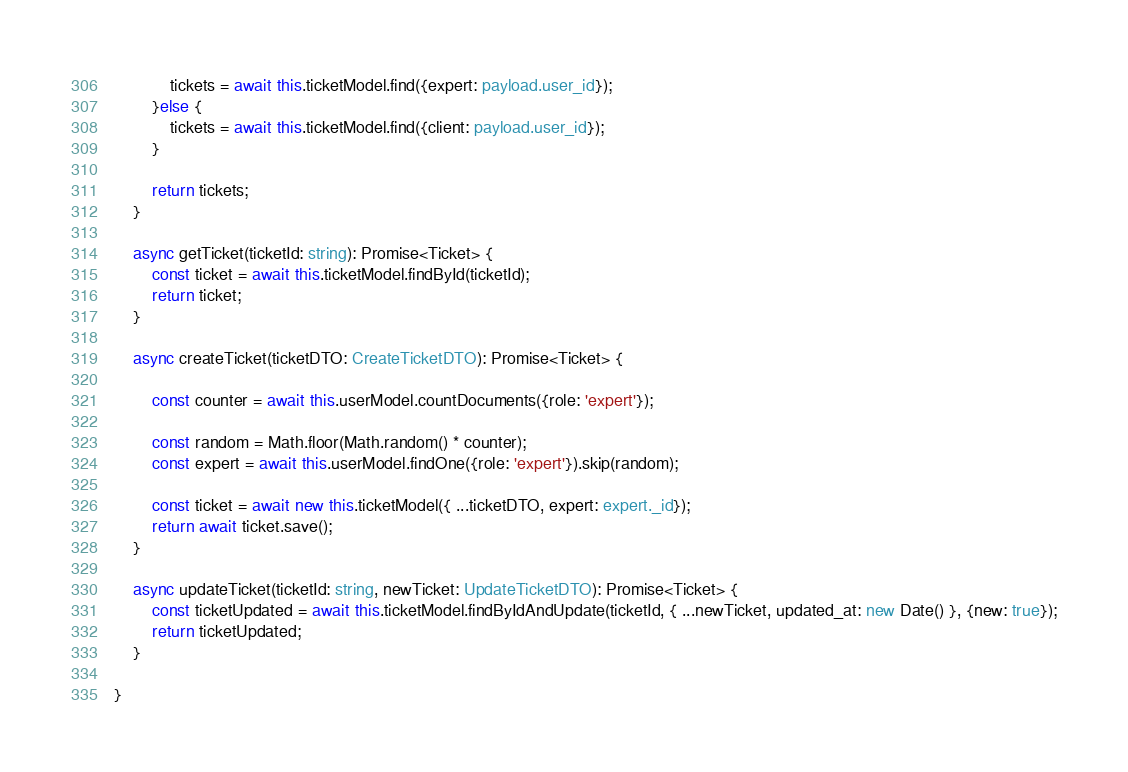Convert code to text. <code><loc_0><loc_0><loc_500><loc_500><_TypeScript_>            tickets = await this.ticketModel.find({expert: payload.user_id});
        }else {
            tickets = await this.ticketModel.find({client: payload.user_id});
        }
        
        return tickets;
    }

    async getTicket(ticketId: string): Promise<Ticket> {
        const ticket = await this.ticketModel.findById(ticketId);
        return ticket;
    }

    async createTicket(ticketDTO: CreateTicketDTO): Promise<Ticket> {

        const counter = await this.userModel.countDocuments({role: 'expert'});

        const random = Math.floor(Math.random() * counter);
        const expert = await this.userModel.findOne({role: 'expert'}).skip(random);
        
        const ticket = await new this.ticketModel({ ...ticketDTO, expert: expert._id});
        return await ticket.save();
    }

    async updateTicket(ticketId: string, newTicket: UpdateTicketDTO): Promise<Ticket> {
        const ticketUpdated = await this.ticketModel.findByIdAndUpdate(ticketId, { ...newTicket, updated_at: new Date() }, {new: true});
        return ticketUpdated;
    }

}</code> 